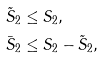<formula> <loc_0><loc_0><loc_500><loc_500>\tilde { S } _ { 2 } & \leq S _ { 2 } , \\ \bar { S } _ { 2 } & \leq S _ { 2 } - \tilde { S } _ { 2 } ,</formula> 